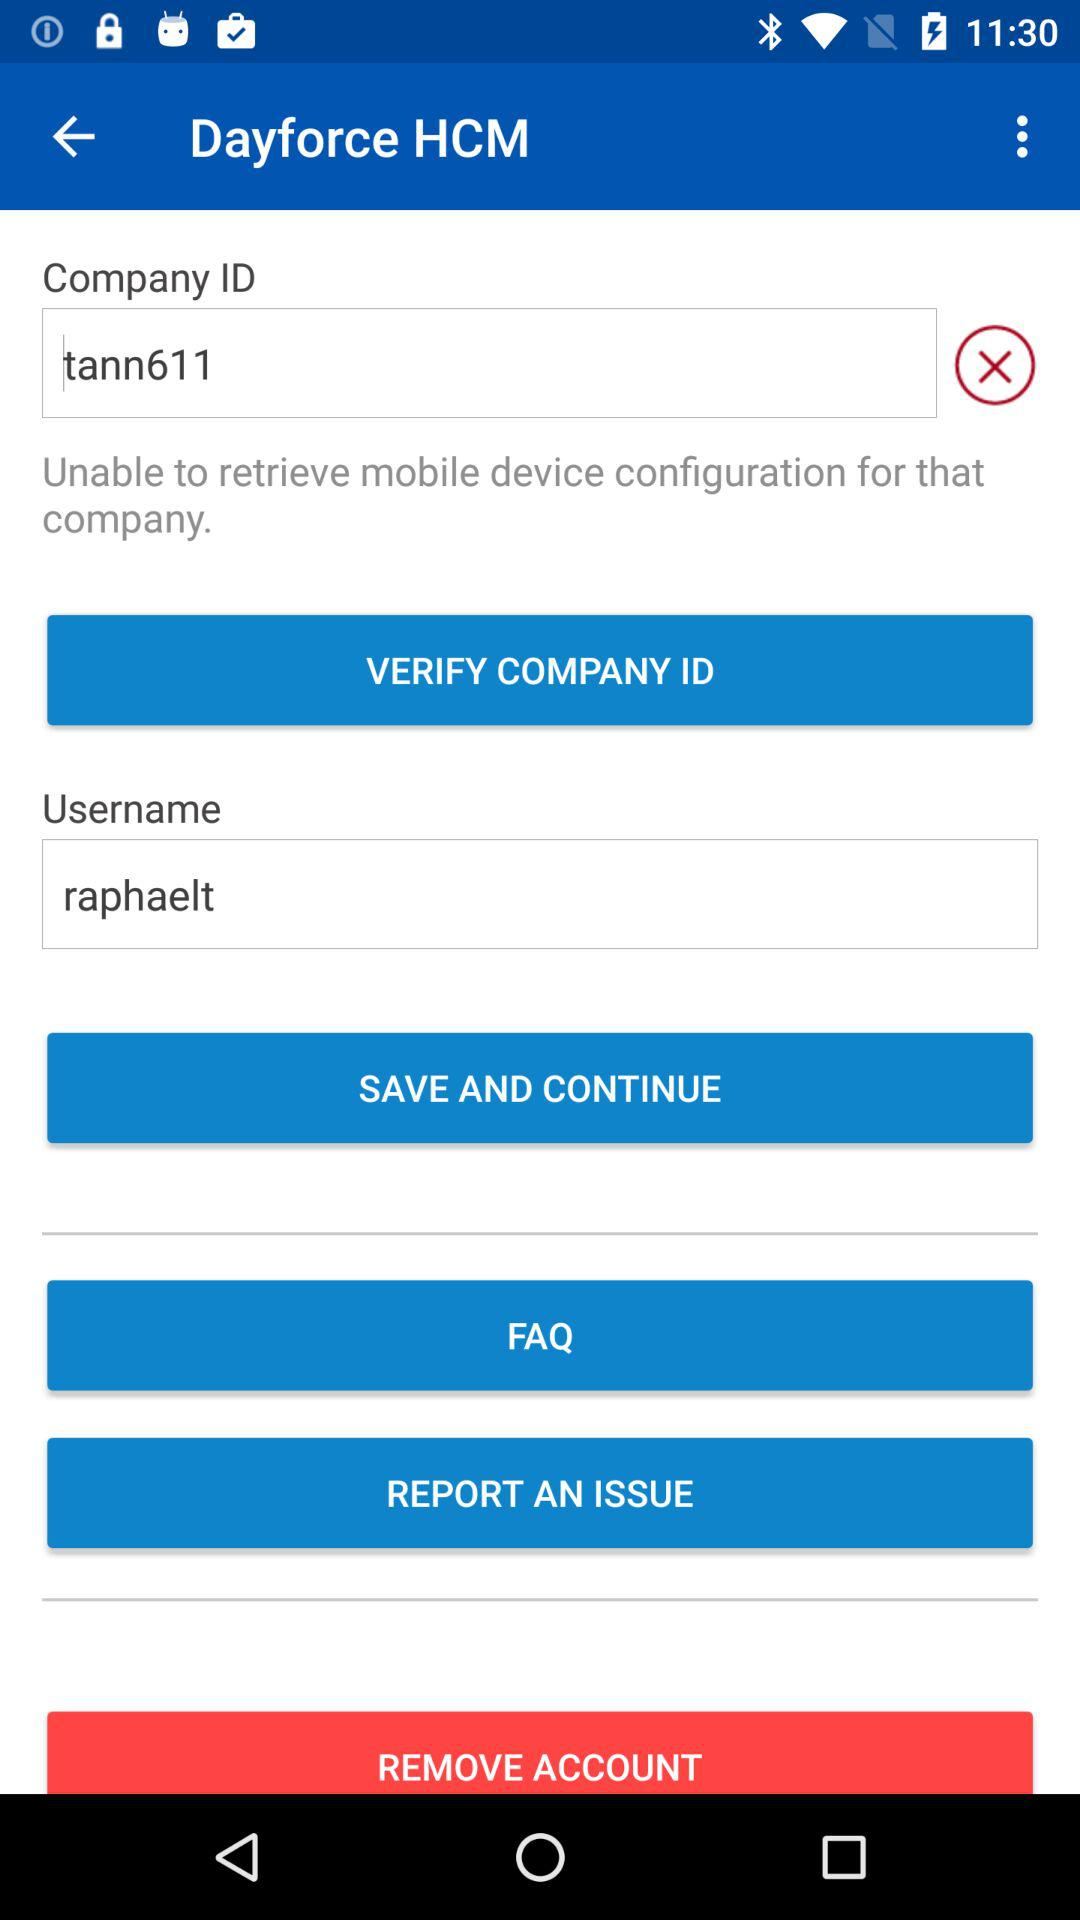How do I report an issue?
When the provided information is insufficient, respond with <no answer>. <no answer> 